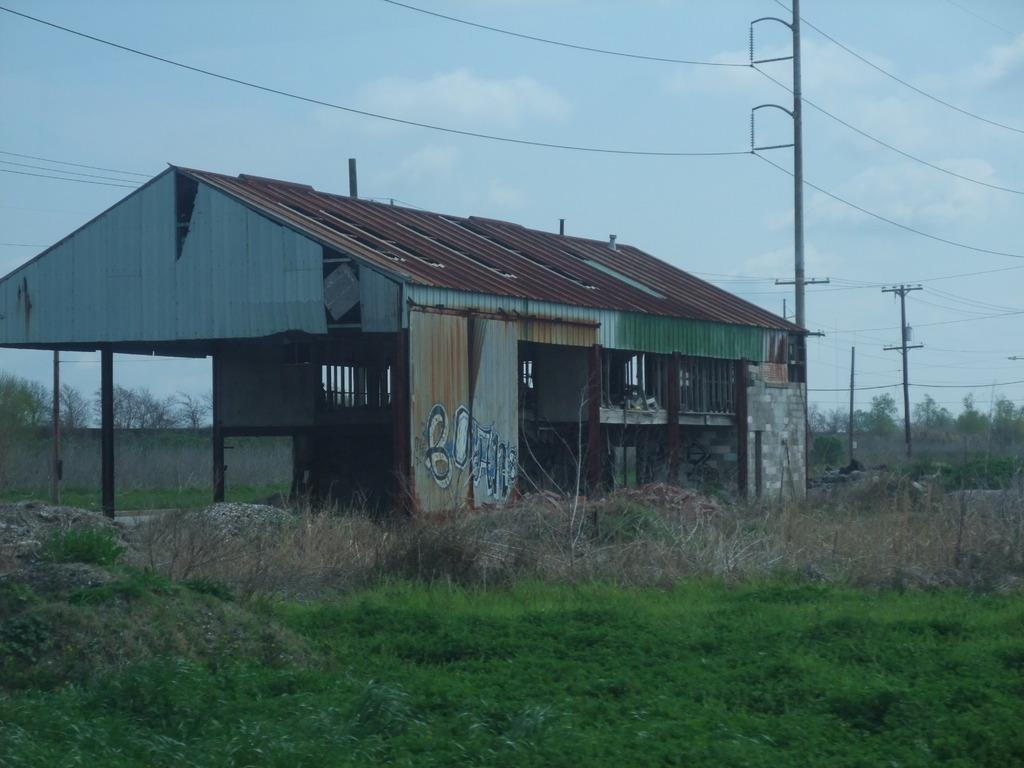What type of structure is present in the image? There is a shed in the image. What type of vegetation is visible in the image? There is grass in the image. What other natural elements can be seen in the image? There are trees in the image. What are the poles used for in the image? The purpose of the poles in the image is not specified, but they are present. Where is the stick used for cooking located in the image? There is no stick used for cooking present in the image. What type of oven is visible in the image? There is no oven present in the image. Is there a bed visible in the image? There is no bed present in the image. 